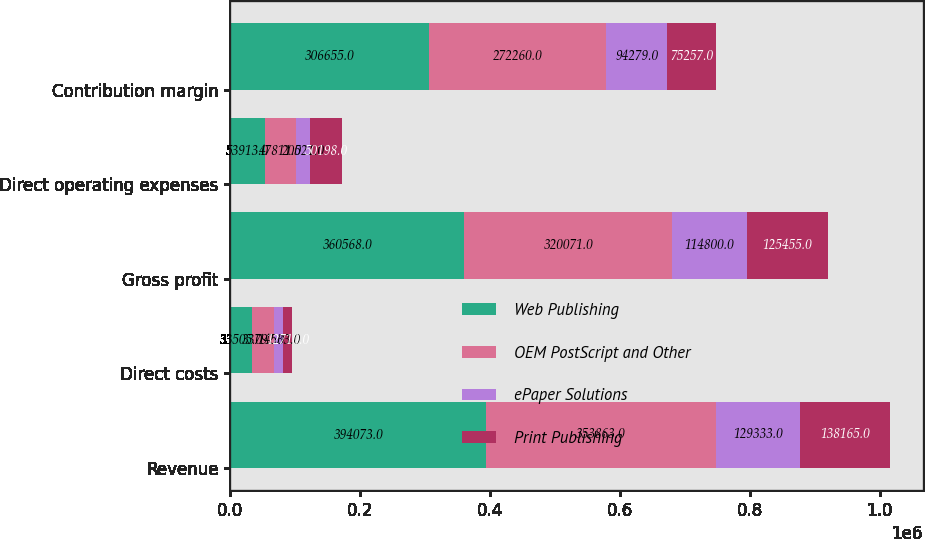Convert chart. <chart><loc_0><loc_0><loc_500><loc_500><stacked_bar_chart><ecel><fcel>Revenue<fcel>Direct costs<fcel>Gross profit<fcel>Direct operating expenses<fcel>Contribution margin<nl><fcel>Web Publishing<fcel>394073<fcel>33505<fcel>360568<fcel>53913<fcel>306655<nl><fcel>OEM PostScript and Other<fcel>353863<fcel>33792<fcel>320071<fcel>47811<fcel>272260<nl><fcel>ePaper Solutions<fcel>129333<fcel>14533<fcel>114800<fcel>20521<fcel>94279<nl><fcel>Print Publishing<fcel>138165<fcel>12710<fcel>125455<fcel>50198<fcel>75257<nl></chart> 